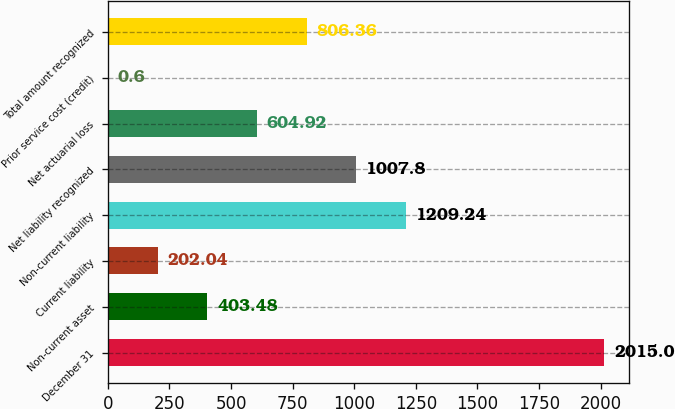Convert chart to OTSL. <chart><loc_0><loc_0><loc_500><loc_500><bar_chart><fcel>December 31<fcel>Non-current asset<fcel>Current liability<fcel>Non-current liability<fcel>Net liability recognized<fcel>Net actuarial loss<fcel>Prior service cost (credit)<fcel>Total amount recognized<nl><fcel>2015<fcel>403.48<fcel>202.04<fcel>1209.24<fcel>1007.8<fcel>604.92<fcel>0.6<fcel>806.36<nl></chart> 